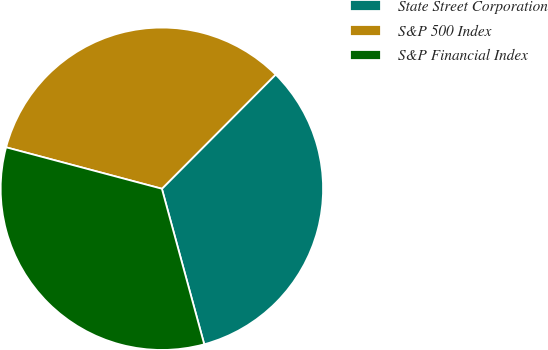Convert chart. <chart><loc_0><loc_0><loc_500><loc_500><pie_chart><fcel>State Street Corporation<fcel>S&P 500 Index<fcel>S&P Financial Index<nl><fcel>33.3%<fcel>33.33%<fcel>33.37%<nl></chart> 